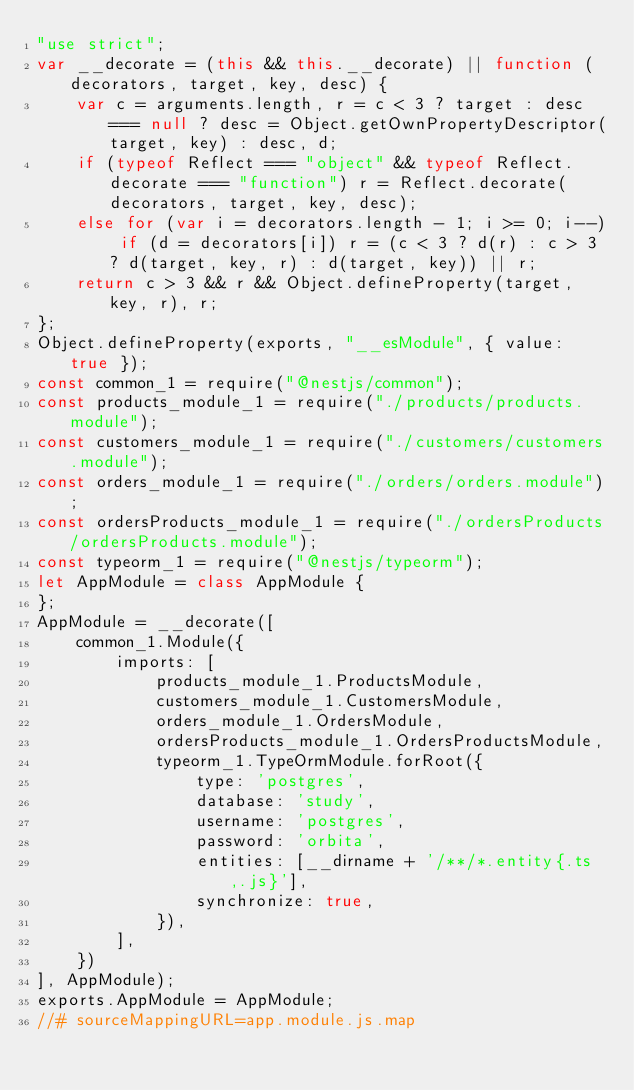<code> <loc_0><loc_0><loc_500><loc_500><_JavaScript_>"use strict";
var __decorate = (this && this.__decorate) || function (decorators, target, key, desc) {
    var c = arguments.length, r = c < 3 ? target : desc === null ? desc = Object.getOwnPropertyDescriptor(target, key) : desc, d;
    if (typeof Reflect === "object" && typeof Reflect.decorate === "function") r = Reflect.decorate(decorators, target, key, desc);
    else for (var i = decorators.length - 1; i >= 0; i--) if (d = decorators[i]) r = (c < 3 ? d(r) : c > 3 ? d(target, key, r) : d(target, key)) || r;
    return c > 3 && r && Object.defineProperty(target, key, r), r;
};
Object.defineProperty(exports, "__esModule", { value: true });
const common_1 = require("@nestjs/common");
const products_module_1 = require("./products/products.module");
const customers_module_1 = require("./customers/customers.module");
const orders_module_1 = require("./orders/orders.module");
const ordersProducts_module_1 = require("./ordersProducts/ordersProducts.module");
const typeorm_1 = require("@nestjs/typeorm");
let AppModule = class AppModule {
};
AppModule = __decorate([
    common_1.Module({
        imports: [
            products_module_1.ProductsModule,
            customers_module_1.CustomersModule,
            orders_module_1.OrdersModule,
            ordersProducts_module_1.OrdersProductsModule,
            typeorm_1.TypeOrmModule.forRoot({
                type: 'postgres',
                database: 'study',
                username: 'postgres',
                password: 'orbita',
                entities: [__dirname + '/**/*.entity{.ts,.js}'],
                synchronize: true,
            }),
        ],
    })
], AppModule);
exports.AppModule = AppModule;
//# sourceMappingURL=app.module.js.map</code> 